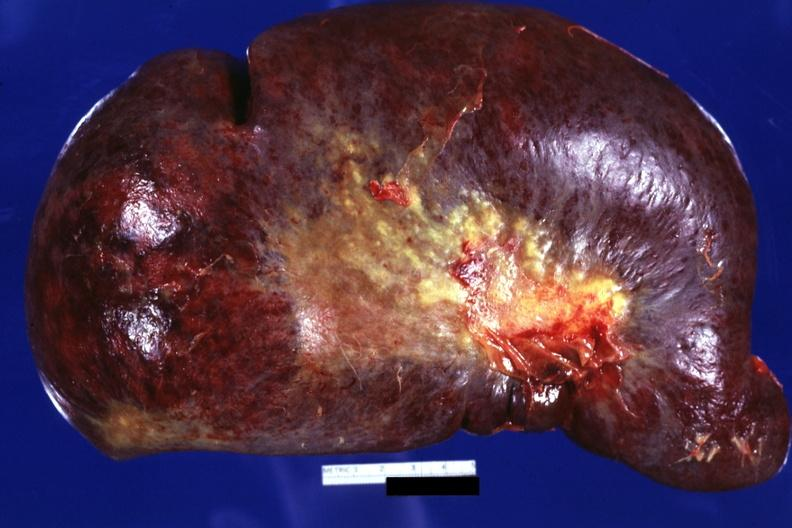s infant body present?
Answer the question using a single word or phrase. No 